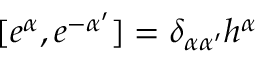<formula> <loc_0><loc_0><loc_500><loc_500>[ e ^ { \alpha } , e ^ { - \alpha ^ { \prime } } ] = \delta _ { \alpha \alpha ^ { \prime } } h ^ { \alpha }</formula> 